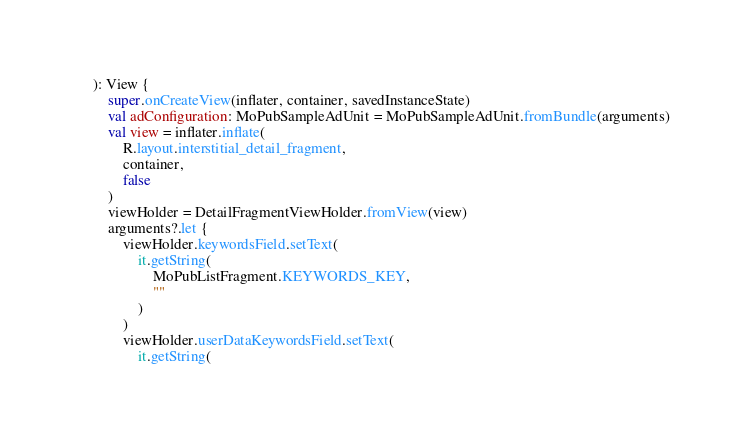<code> <loc_0><loc_0><loc_500><loc_500><_Kotlin_>    ): View {
        super.onCreateView(inflater, container, savedInstanceState)
        val adConfiguration: MoPubSampleAdUnit = MoPubSampleAdUnit.fromBundle(arguments)
        val view = inflater.inflate(
            R.layout.interstitial_detail_fragment,
            container,
            false
        )
        viewHolder = DetailFragmentViewHolder.fromView(view)
        arguments?.let {
            viewHolder.keywordsField.setText(
                it.getString(
                    MoPubListFragment.KEYWORDS_KEY,
                    ""
                )
            )
            viewHolder.userDataKeywordsField.setText(
                it.getString(</code> 